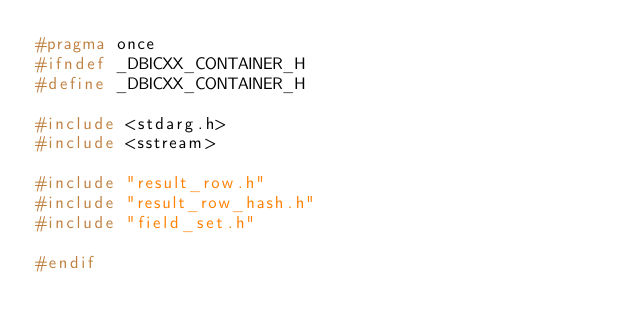Convert code to text. <code><loc_0><loc_0><loc_500><loc_500><_C_>#pragma once
#ifndef _DBICXX_CONTAINER_H
#define _DBICXX_CONTAINER_H

#include <stdarg.h>
#include <sstream>

#include "result_row.h"
#include "result_row_hash.h"
#include "field_set.h"

#endif
</code> 